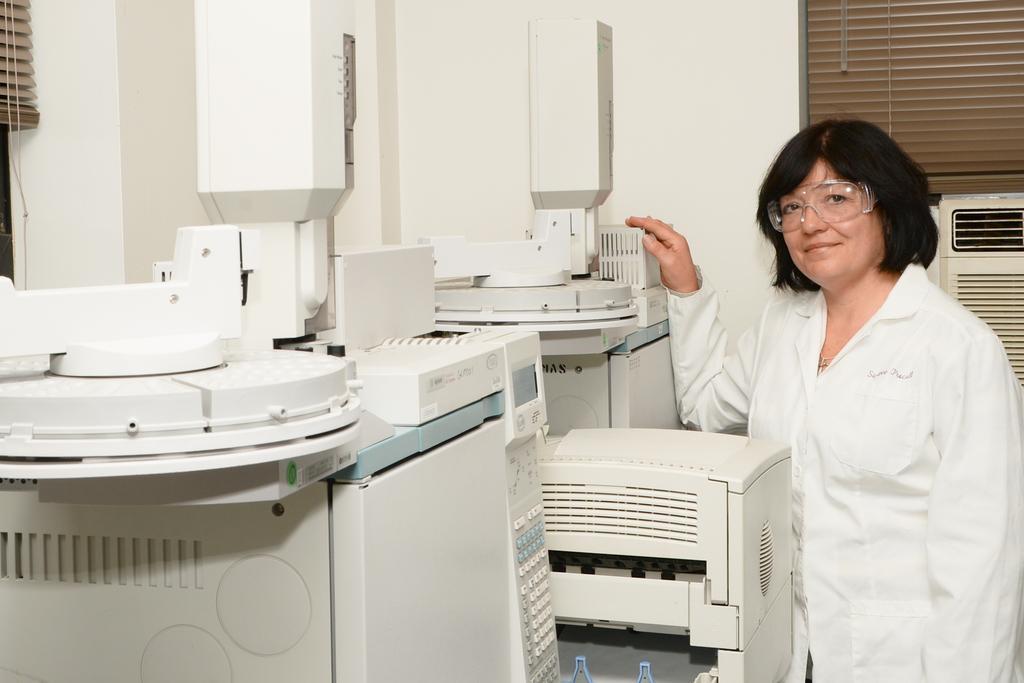Could you give a brief overview of what you see in this image? In this image there are machines, beside the machine, there a woman is standing, in the background there is a wall for that wall there is a window. 